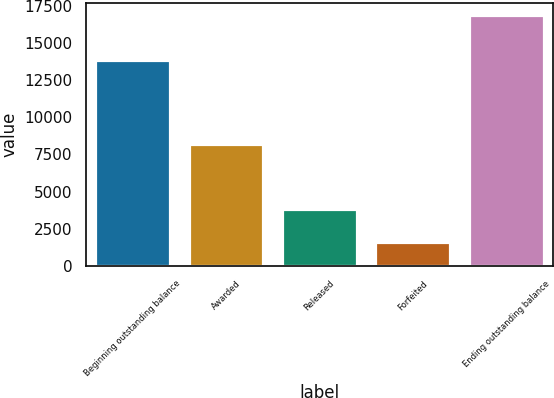Convert chart. <chart><loc_0><loc_0><loc_500><loc_500><bar_chart><fcel>Beginning outstanding balance<fcel>Awarded<fcel>Released<fcel>Forfeited<fcel>Ending outstanding balance<nl><fcel>13890<fcel>8180<fcel>3819<fcel>1587<fcel>16871<nl></chart> 